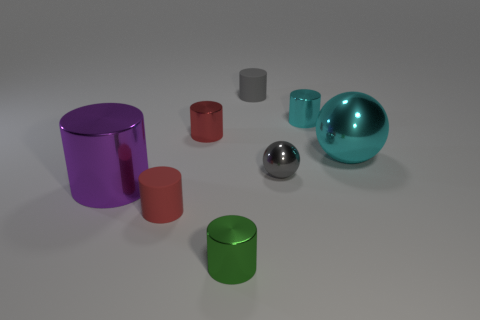There is another object that is the same shape as the large cyan object; what is its material?
Ensure brevity in your answer.  Metal. What is the color of the other metallic thing that is the same shape as the gray metal object?
Ensure brevity in your answer.  Cyan. What number of big red shiny spheres are there?
Your answer should be compact. 0. Are the big object that is to the right of the small gray matte cylinder and the green cylinder made of the same material?
Give a very brief answer. Yes. Is there any other thing that has the same material as the cyan cylinder?
Keep it short and to the point. Yes. How many green objects are in front of the tiny rubber cylinder that is right of the red cylinder behind the large sphere?
Your response must be concise. 1. The cyan cylinder has what size?
Keep it short and to the point. Small. Is the color of the big ball the same as the small metal ball?
Provide a short and direct response. No. What is the size of the matte thing in front of the cyan cylinder?
Ensure brevity in your answer.  Small. There is a large thing that is to the left of the big cyan ball; is it the same color as the tiny metal cylinder on the right side of the small gray rubber cylinder?
Ensure brevity in your answer.  No. 